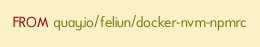<code> <loc_0><loc_0><loc_500><loc_500><_Dockerfile_>FROM quay.io/feliun/docker-nvm-npmrc</code> 